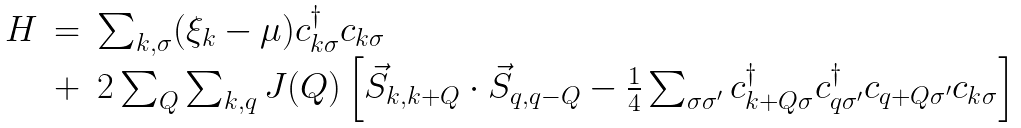Convert formula to latex. <formula><loc_0><loc_0><loc_500><loc_500>\begin{array} { l l l } H & = & \sum _ { k , \sigma } ( \xi _ { k } - \mu ) c _ { k \sigma } ^ { \dagger } c _ { k \sigma } \\ & + & 2 \sum _ { Q } \sum _ { k , q } J ( Q ) \left [ \vec { S } _ { k , k + Q } \cdot \vec { S } _ { q , q - Q } - \frac { 1 } { 4 } \sum _ { \sigma \sigma ^ { \prime } } c _ { k + Q \sigma } ^ { \dagger } c _ { q \sigma ^ { \prime } } ^ { \dagger } c _ { q + Q \sigma ^ { \prime } } c _ { k \sigma } \right ] \end{array}</formula> 